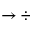<formula> <loc_0><loc_0><loc_500><loc_500>\rightarrow \div</formula> 